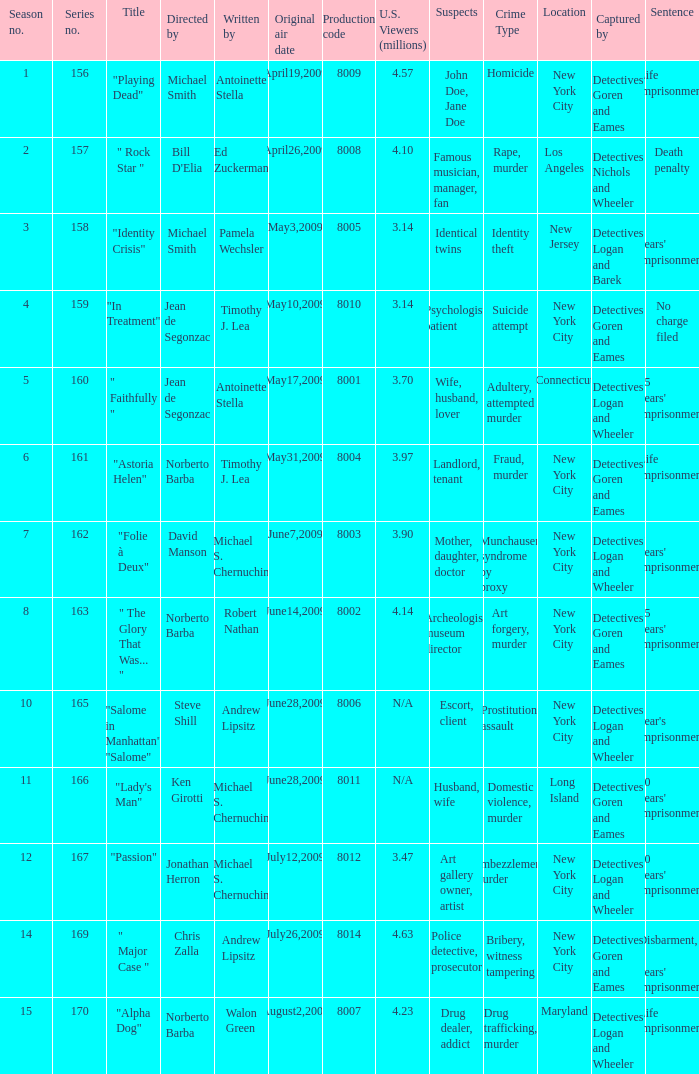How many writers write the episode whose director is Jonathan Herron? 1.0. Would you mind parsing the complete table? {'header': ['Season no.', 'Series no.', 'Title', 'Directed by', 'Written by', 'Original air date', 'Production code', 'U.S. Viewers (millions)', 'Suspects', 'Crime Type', 'Location', 'Captured by', 'Sentence'], 'rows': [['1', '156', '"Playing Dead"', 'Michael Smith', 'Antoinette Stella', 'April19,2009', '8009', '4.57', 'John Doe, Jane Doe', 'Homicide', 'New York City', 'Detectives Goren and Eames', 'Life imprisonment'], ['2', '157', '" Rock Star "', "Bill D'Elia", 'Ed Zuckerman', 'April26,2009', '8008', '4.10', 'Famous musician, manager, fan', 'Rape, murder', 'Los Angeles', 'Detectives Nichols and Wheeler', 'Death penalty'], ['3', '158', '"Identity Crisis"', 'Michael Smith', 'Pamela Wechsler', 'May3,2009', '8005', '3.14', 'Identical twins', 'Identity theft', 'New Jersey', 'Detectives Logan and Barek', "5 years' imprisonment"], ['4', '159', '"In Treatment"', 'Jean de Segonzac', 'Timothy J. Lea', 'May10,2009', '8010', '3.14', 'Psychologist, patient', 'Suicide attempt', 'New York City', 'Detectives Goren and Eames', 'No charge filed'], ['5', '160', '" Faithfully "', 'Jean de Segonzac', 'Antoinette Stella', 'May17,2009', '8001', '3.70', 'Wife, husband, lover', 'Adultery, attempted murder', 'Connecticut', 'Detectives Logan and Wheeler', "15 years' imprisonment"], ['6', '161', '"Astoria Helen"', 'Norberto Barba', 'Timothy J. Lea', 'May31,2009', '8004', '3.97', 'Landlord, tenant', 'Fraud, murder', 'New York City', 'Detectives Goren and Eames', 'Life imprisonment'], ['7', '162', '"Folie à Deux"', 'David Manson', 'Michael S. Chernuchin', 'June7,2009', '8003', '3.90', 'Mother, daughter, doctor', 'Munchausen syndrome by proxy', 'New York City', 'Detectives Logan and Wheeler', "6 years' imprisonment"], ['8', '163', '" The Glory That Was... "', 'Norberto Barba', 'Robert Nathan', 'June14,2009', '8002', '4.14', 'Archeologist, museum director', 'Art forgery, murder', 'New York City', 'Detectives Goren and Eames', "25 years' imprisonment"], ['10', '165', '"Salome in Manhattan" "Salome"', 'Steve Shill', 'Andrew Lipsitz', 'June28,2009', '8006', 'N/A', 'Escort, client', 'Prostitution, assault', 'New York City', 'Detectives Logan and Wheeler', "1 year's imprisonment"], ['11', '166', '"Lady\'s Man"', 'Ken Girotti', 'Michael S. Chernuchin', 'June28,2009', '8011', 'N/A', 'Husband, wife', 'Domestic violence, murder', 'Long Island', 'Detectives Goren and Eames', "20 years' imprisonment"], ['12', '167', '"Passion"', 'Jonathan Herron', 'Michael S. Chernuchin', 'July12,2009', '8012', '3.47', 'Art gallery owner, artist', 'Embezzlement, murder', 'New York City', 'Detectives Logan and Wheeler', "30 years' imprisonment"], ['14', '169', '" Major Case "', 'Chris Zalla', 'Andrew Lipsitz', 'July26,2009', '8014', '4.63', 'Police detective, prosecutor', 'Bribery, witness tampering', 'New York City', 'Detectives Goren and Eames', "Disbarment, 5 years' imprisonment"], ['15', '170', '"Alpha Dog"', 'Norberto Barba', 'Walon Green', 'August2,2009', '8007', '4.23', 'Drug dealer, addict', 'Drug trafficking, murder', 'Maryland', 'Detectives Logan and Wheeler', 'Life imprisonment']]} 